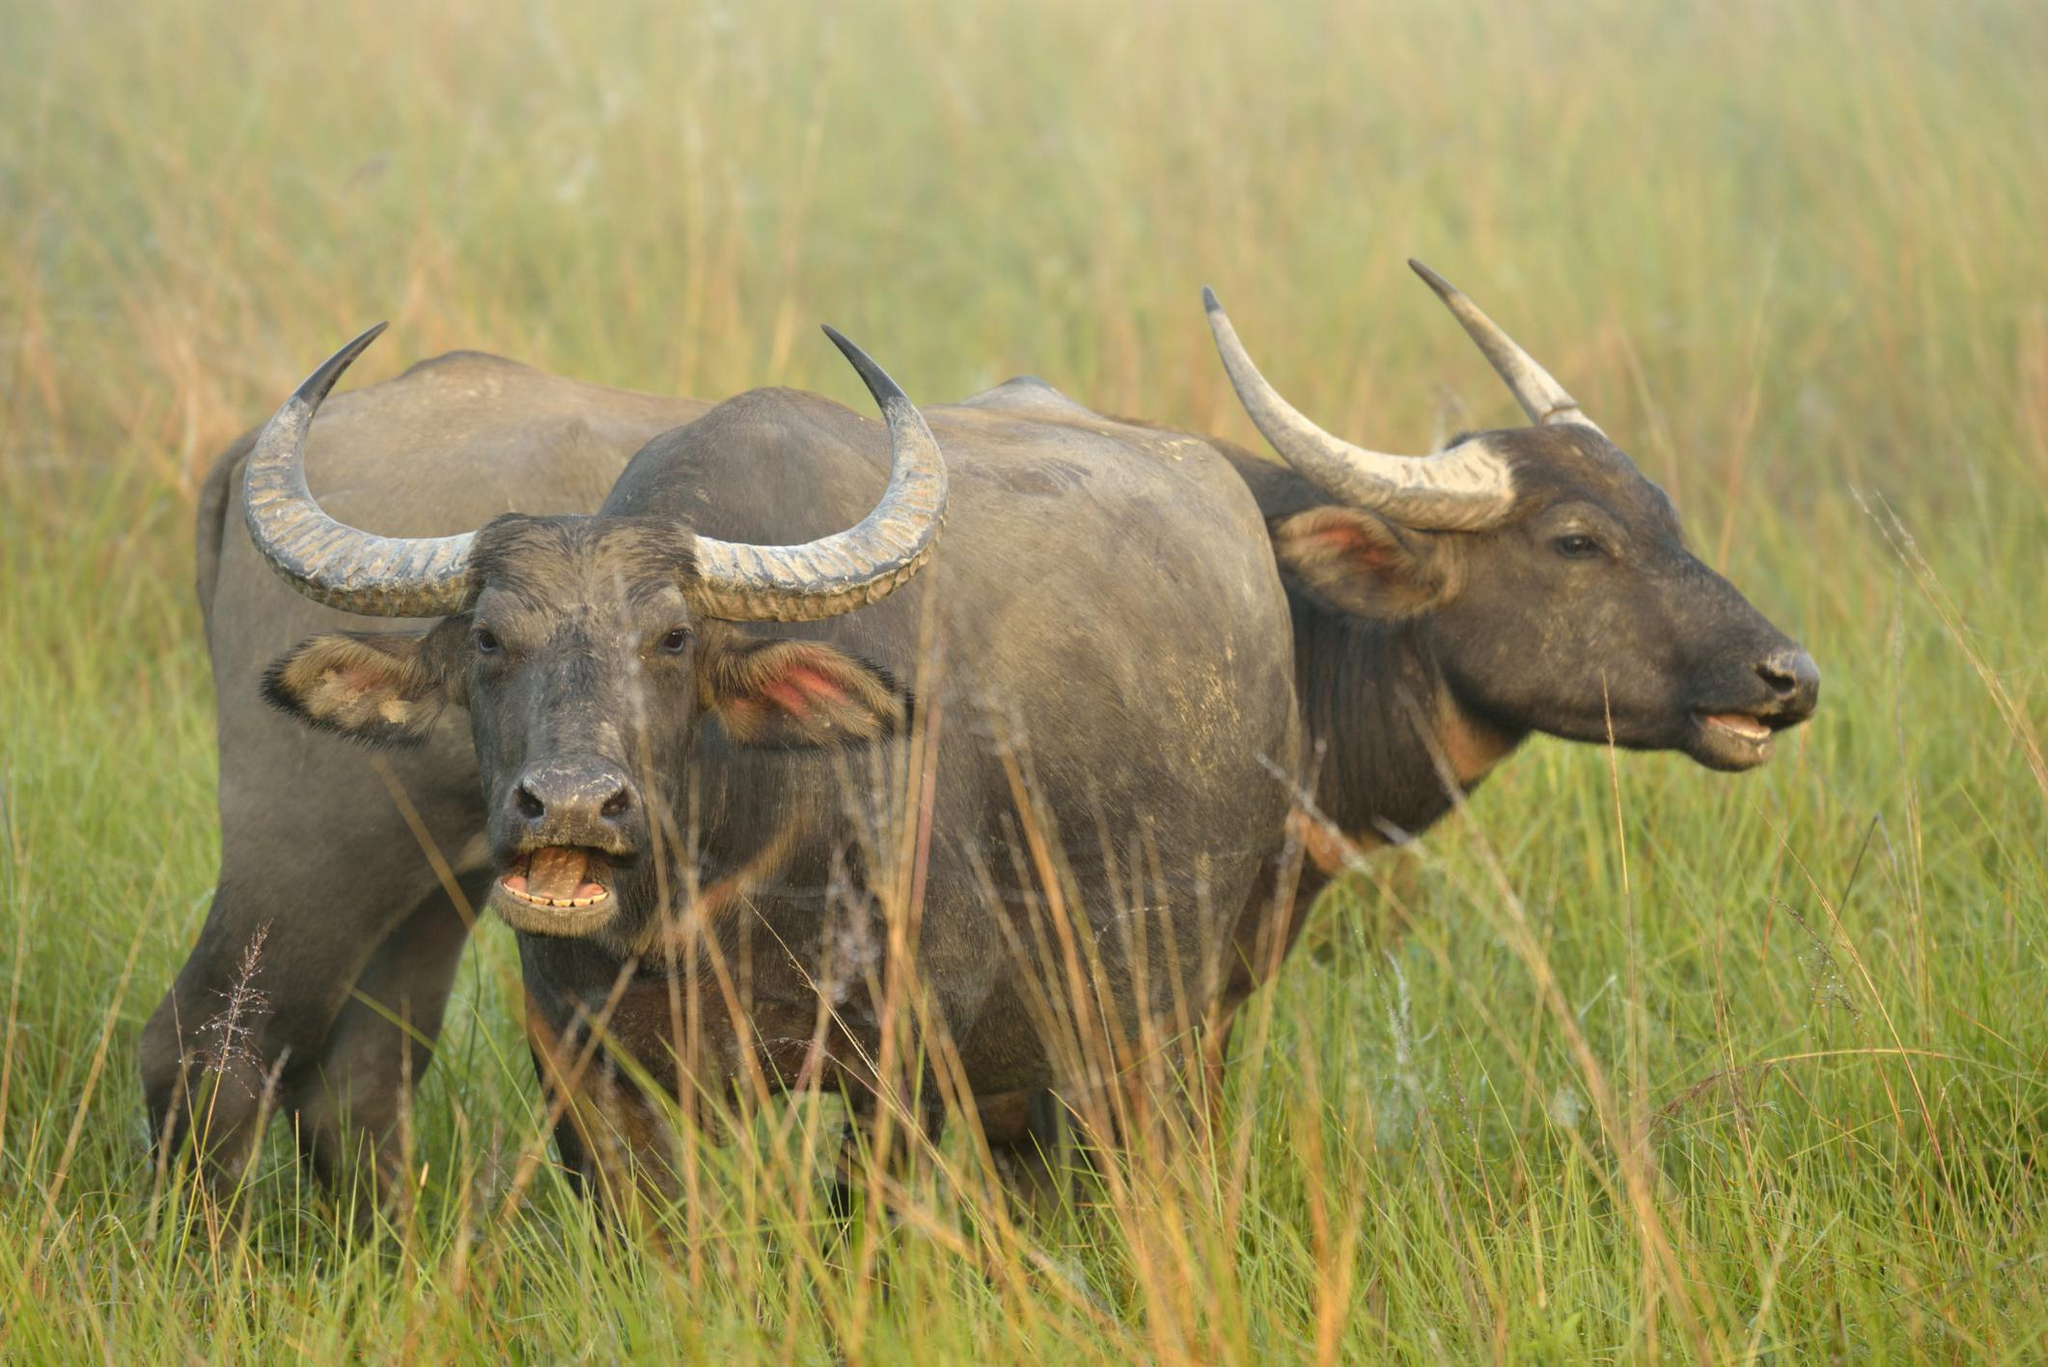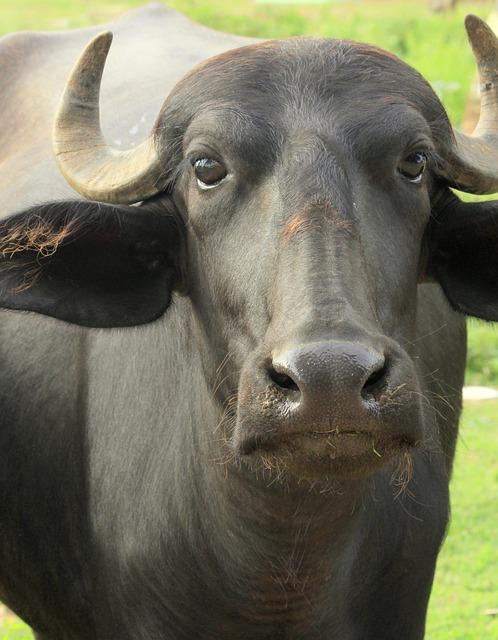The first image is the image on the left, the second image is the image on the right. For the images shown, is this caption "Each image includes one water buffalo who is looking straight ahead at the camera and who does not have a rope strung in its nose." true? Answer yes or no. Yes. The first image is the image on the left, the second image is the image on the right. Examine the images to the left and right. Is the description "There are three animals." accurate? Answer yes or no. Yes. 